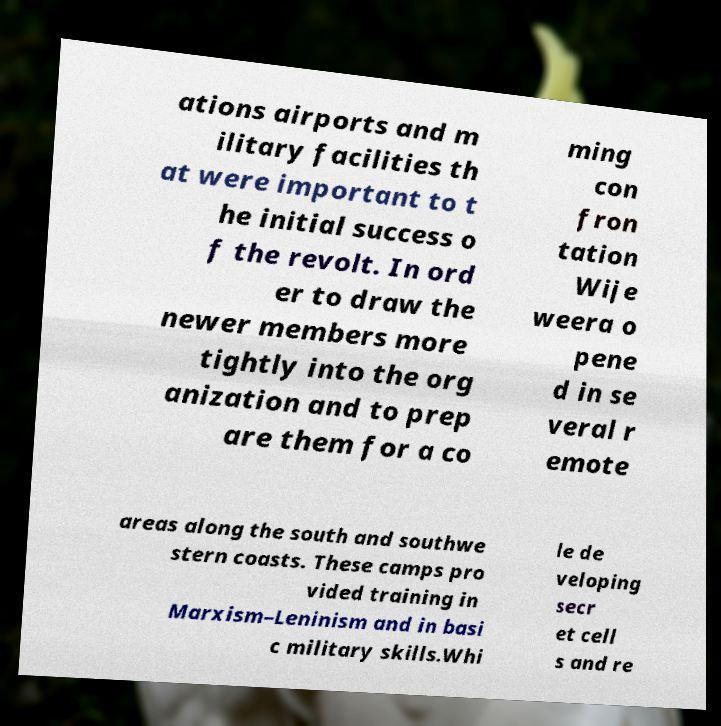For documentation purposes, I need the text within this image transcribed. Could you provide that? ations airports and m ilitary facilities th at were important to t he initial success o f the revolt. In ord er to draw the newer members more tightly into the org anization and to prep are them for a co ming con fron tation Wije weera o pene d in se veral r emote areas along the south and southwe stern coasts. These camps pro vided training in Marxism–Leninism and in basi c military skills.Whi le de veloping secr et cell s and re 